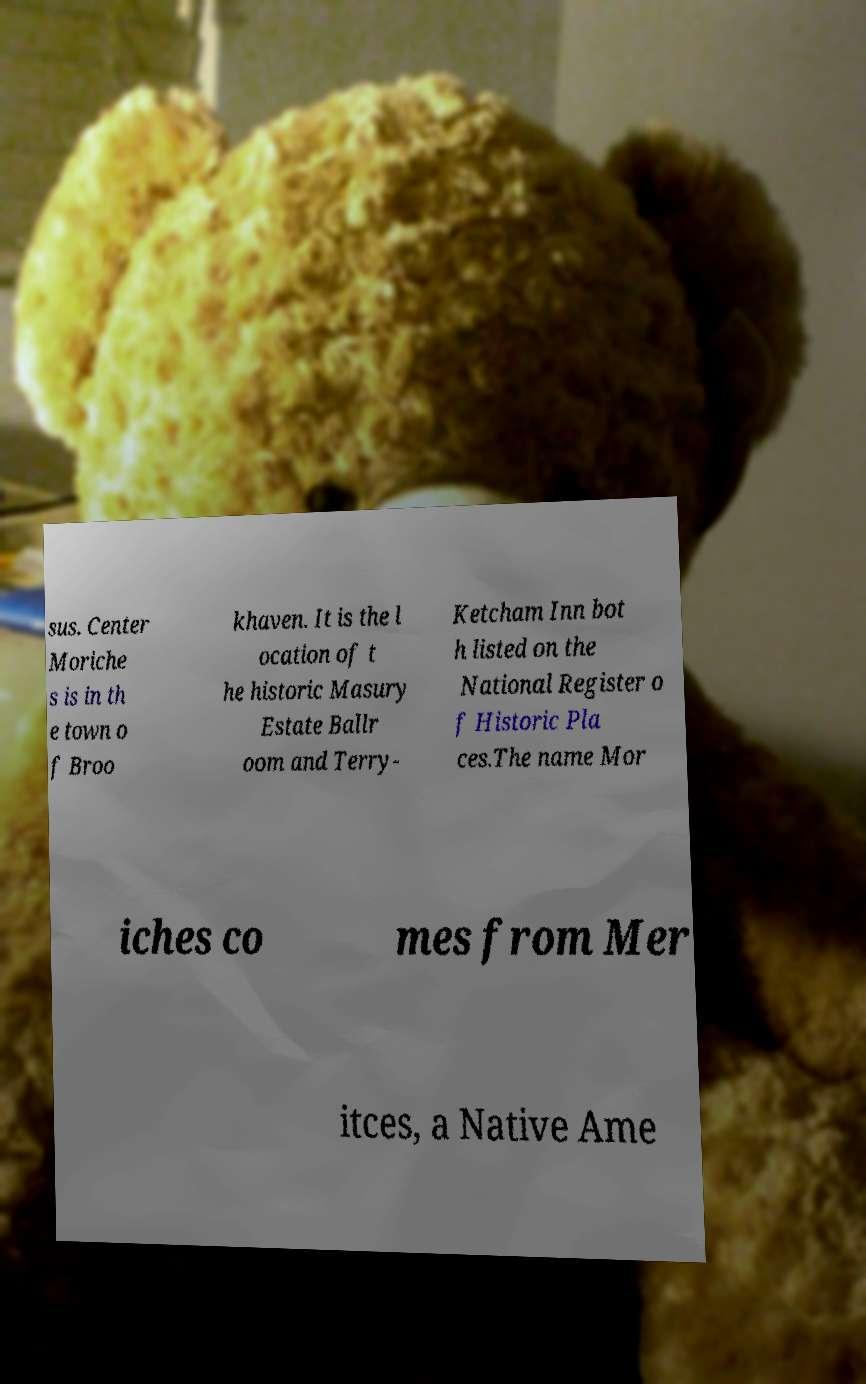Could you assist in decoding the text presented in this image and type it out clearly? sus. Center Moriche s is in th e town o f Broo khaven. It is the l ocation of t he historic Masury Estate Ballr oom and Terry- Ketcham Inn bot h listed on the National Register o f Historic Pla ces.The name Mor iches co mes from Mer itces, a Native Ame 